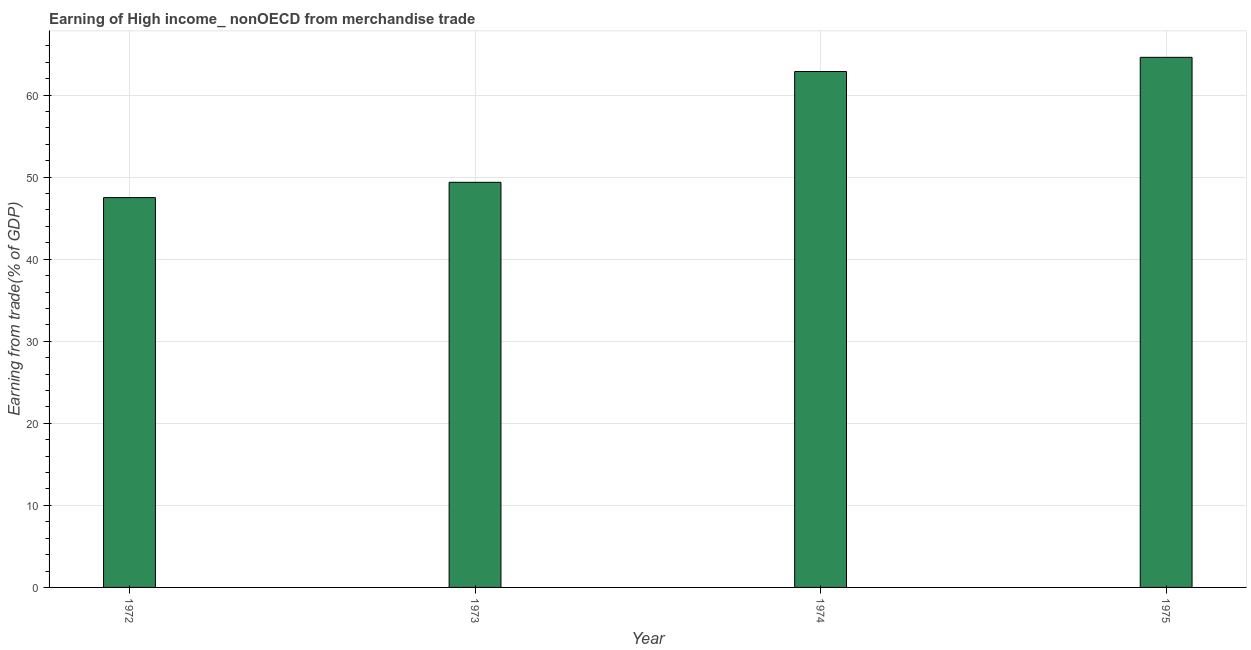Does the graph contain any zero values?
Make the answer very short. No. What is the title of the graph?
Your answer should be very brief. Earning of High income_ nonOECD from merchandise trade. What is the label or title of the Y-axis?
Your answer should be very brief. Earning from trade(% of GDP). What is the earning from merchandise trade in 1974?
Your answer should be compact. 62.87. Across all years, what is the maximum earning from merchandise trade?
Your answer should be compact. 64.6. Across all years, what is the minimum earning from merchandise trade?
Make the answer very short. 47.51. In which year was the earning from merchandise trade maximum?
Make the answer very short. 1975. In which year was the earning from merchandise trade minimum?
Your response must be concise. 1972. What is the sum of the earning from merchandise trade?
Offer a very short reply. 224.35. What is the difference between the earning from merchandise trade in 1972 and 1974?
Keep it short and to the point. -15.37. What is the average earning from merchandise trade per year?
Your response must be concise. 56.09. What is the median earning from merchandise trade?
Your response must be concise. 56.12. In how many years, is the earning from merchandise trade greater than 46 %?
Provide a succinct answer. 4. What is the ratio of the earning from merchandise trade in 1972 to that in 1973?
Your response must be concise. 0.96. What is the difference between the highest and the second highest earning from merchandise trade?
Ensure brevity in your answer.  1.73. In how many years, is the earning from merchandise trade greater than the average earning from merchandise trade taken over all years?
Ensure brevity in your answer.  2. What is the Earning from trade(% of GDP) of 1972?
Your answer should be very brief. 47.51. What is the Earning from trade(% of GDP) in 1973?
Your answer should be compact. 49.37. What is the Earning from trade(% of GDP) of 1974?
Keep it short and to the point. 62.87. What is the Earning from trade(% of GDP) in 1975?
Ensure brevity in your answer.  64.6. What is the difference between the Earning from trade(% of GDP) in 1972 and 1973?
Your answer should be very brief. -1.87. What is the difference between the Earning from trade(% of GDP) in 1972 and 1974?
Keep it short and to the point. -15.37. What is the difference between the Earning from trade(% of GDP) in 1972 and 1975?
Keep it short and to the point. -17.1. What is the difference between the Earning from trade(% of GDP) in 1973 and 1974?
Provide a short and direct response. -13.5. What is the difference between the Earning from trade(% of GDP) in 1973 and 1975?
Your response must be concise. -15.23. What is the difference between the Earning from trade(% of GDP) in 1974 and 1975?
Your answer should be compact. -1.73. What is the ratio of the Earning from trade(% of GDP) in 1972 to that in 1973?
Offer a very short reply. 0.96. What is the ratio of the Earning from trade(% of GDP) in 1972 to that in 1974?
Ensure brevity in your answer.  0.76. What is the ratio of the Earning from trade(% of GDP) in 1972 to that in 1975?
Offer a very short reply. 0.73. What is the ratio of the Earning from trade(% of GDP) in 1973 to that in 1974?
Offer a very short reply. 0.79. What is the ratio of the Earning from trade(% of GDP) in 1973 to that in 1975?
Offer a very short reply. 0.76. 